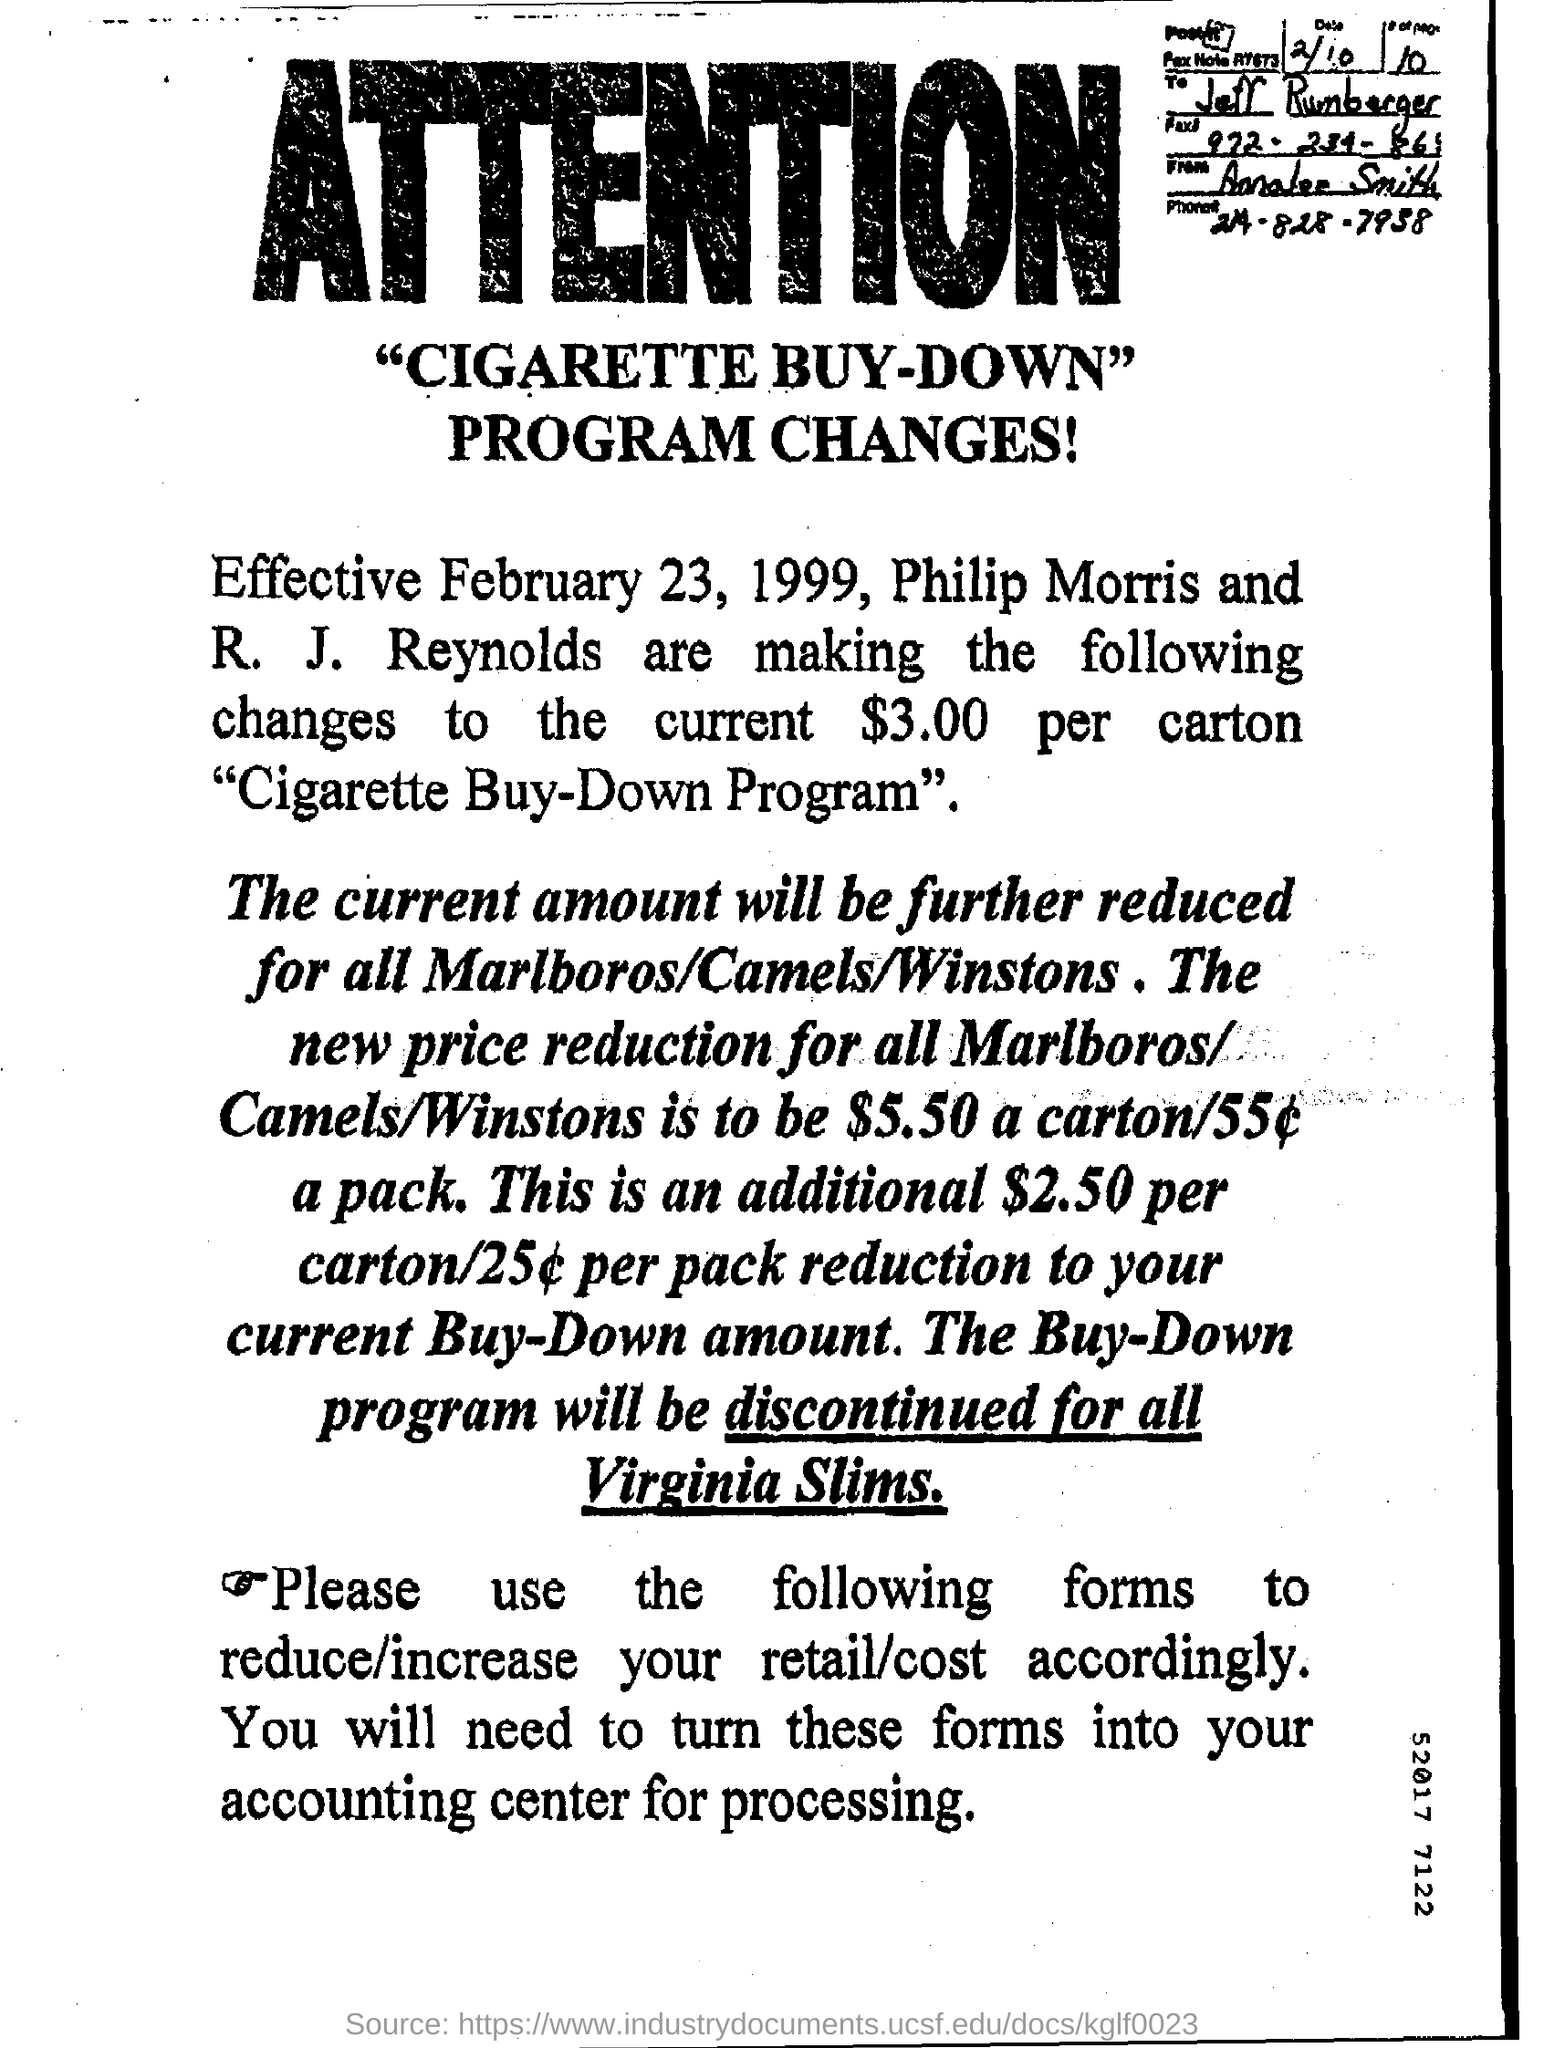What is the phone no. mentioned ?
Ensure brevity in your answer.  214-828-7938. 